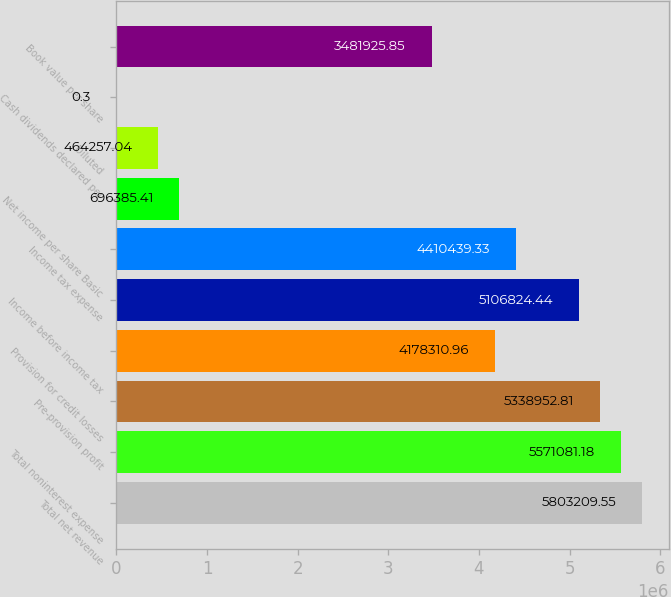<chart> <loc_0><loc_0><loc_500><loc_500><bar_chart><fcel>Total net revenue<fcel>Total noninterest expense<fcel>Pre-provision profit<fcel>Provision for credit losses<fcel>Income before income tax<fcel>Income tax expense<fcel>Net income per share Basic<fcel>Diluted<fcel>Cash dividends declared per<fcel>Book value per share<nl><fcel>5.80321e+06<fcel>5.57108e+06<fcel>5.33895e+06<fcel>4.17831e+06<fcel>5.10682e+06<fcel>4.41044e+06<fcel>696385<fcel>464257<fcel>0.3<fcel>3.48193e+06<nl></chart> 